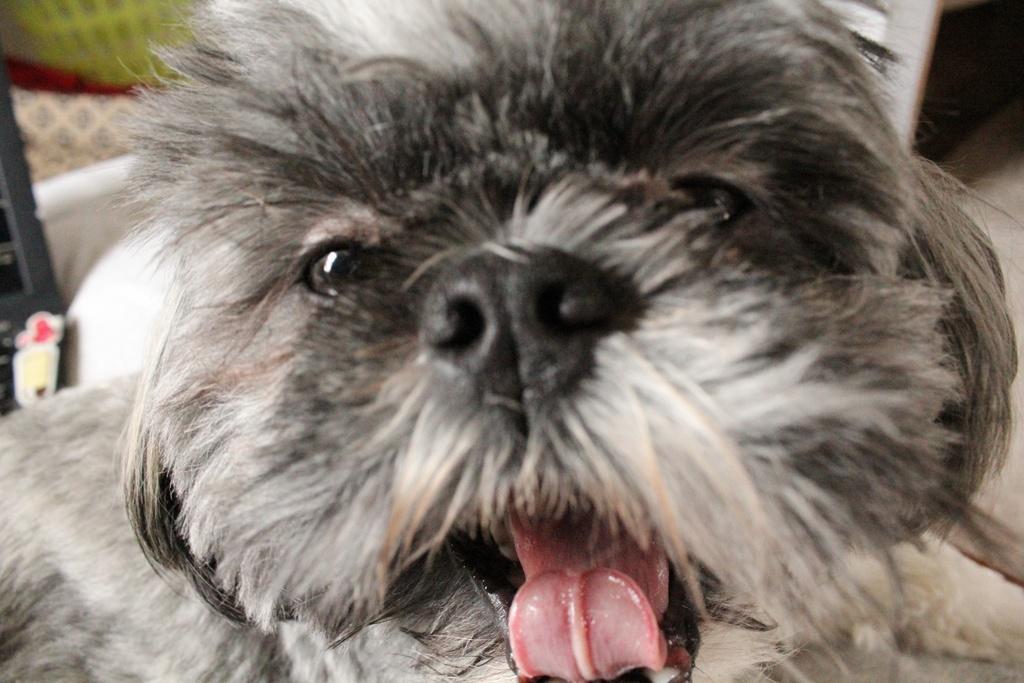Describe this image in one or two sentences. In this image I can see the dog which is in black, white and brown color. I can see there is a blurred background. 